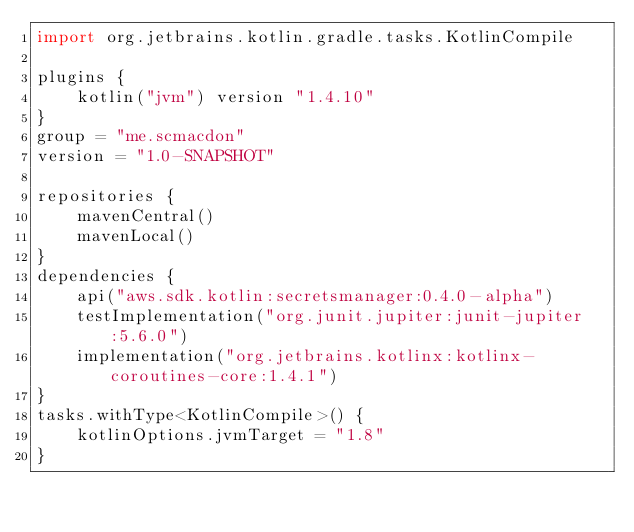Convert code to text. <code><loc_0><loc_0><loc_500><loc_500><_Kotlin_>import org.jetbrains.kotlin.gradle.tasks.KotlinCompile

plugins {
    kotlin("jvm") version "1.4.10"
}
group = "me.scmacdon"
version = "1.0-SNAPSHOT"

repositories {
    mavenCentral()
    mavenLocal()
}
dependencies {
    api("aws.sdk.kotlin:secretsmanager:0.4.0-alpha")
    testImplementation("org.junit.jupiter:junit-jupiter:5.6.0")
    implementation("org.jetbrains.kotlinx:kotlinx-coroutines-core:1.4.1")
}
tasks.withType<KotlinCompile>() {
    kotlinOptions.jvmTarget = "1.8"
}</code> 